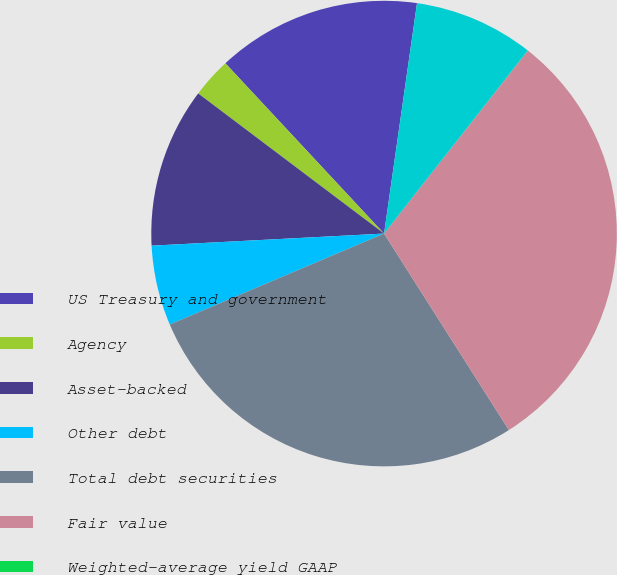<chart> <loc_0><loc_0><loc_500><loc_500><pie_chart><fcel>US Treasury and government<fcel>Agency<fcel>Asset-backed<fcel>Other debt<fcel>Total debt securities<fcel>Fair value<fcel>Weighted-average yield GAAP<fcel>Total debt securities held to<nl><fcel>14.2%<fcel>2.78%<fcel>11.11%<fcel>5.56%<fcel>27.62%<fcel>30.39%<fcel>0.01%<fcel>8.33%<nl></chart> 